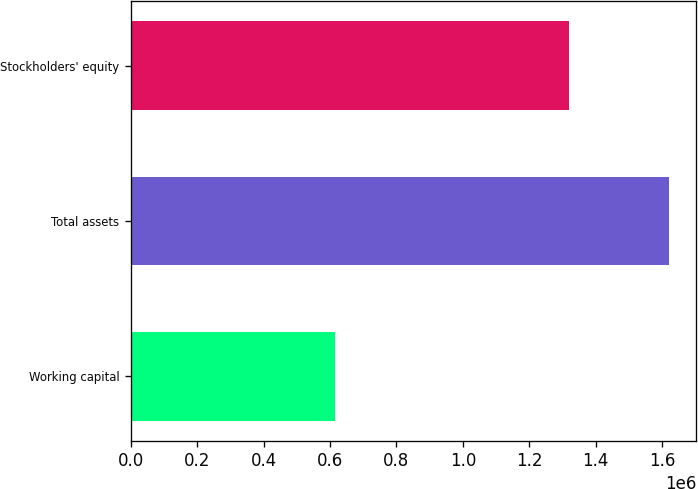Convert chart to OTSL. <chart><loc_0><loc_0><loc_500><loc_500><bar_chart><fcel>Working capital<fcel>Total assets<fcel>Stockholders' equity<nl><fcel>613894<fcel>1.62214e+06<fcel>1.32052e+06<nl></chart> 